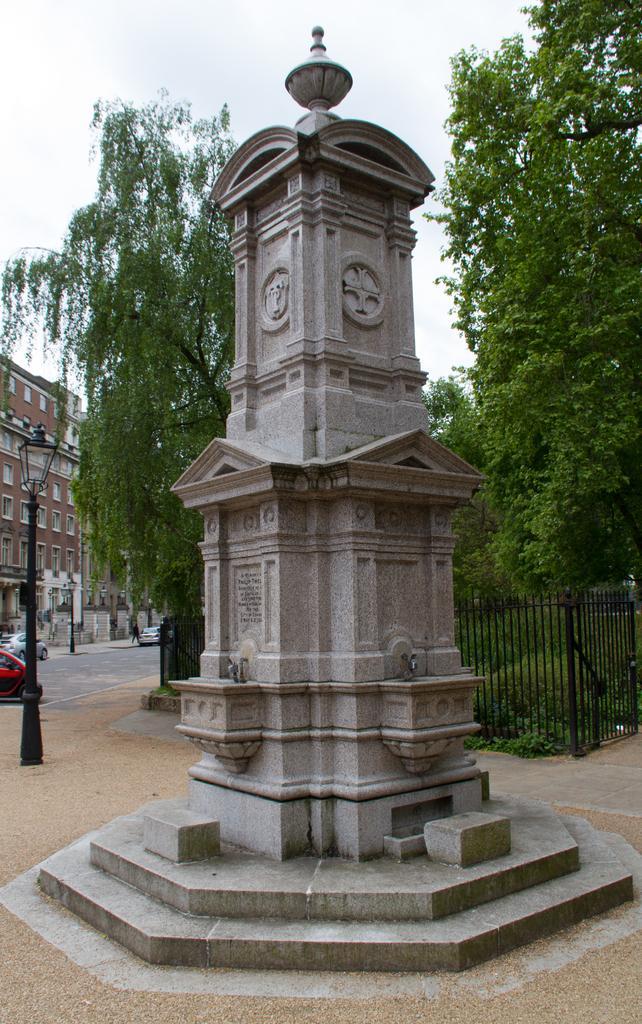Could you give a brief overview of what you see in this image? In this image we can see a monument and in the background of the image there is fencing, there are some trees, buildings and some vehicles which are moving on the road. 